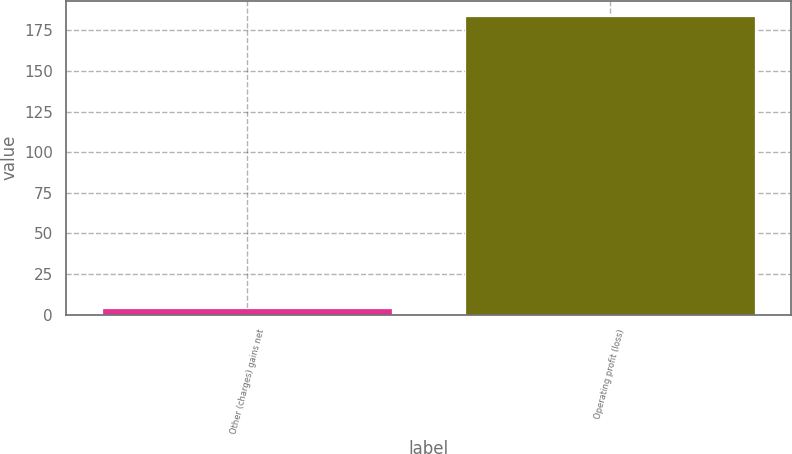Convert chart. <chart><loc_0><loc_0><loc_500><loc_500><bar_chart><fcel>Other (charges) gains net<fcel>Operating profit (loss)<nl><fcel>4<fcel>184<nl></chart> 